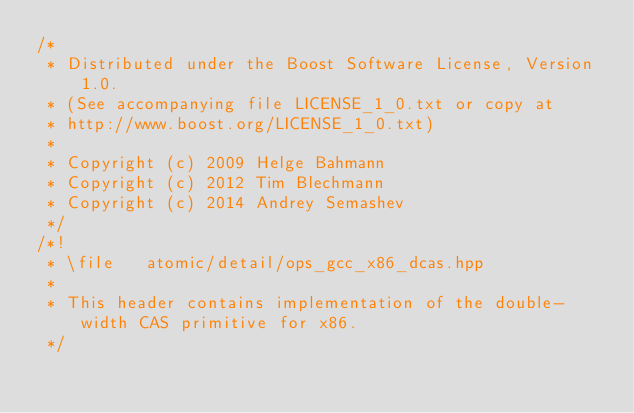<code> <loc_0><loc_0><loc_500><loc_500><_C++_>/*
 * Distributed under the Boost Software License, Version 1.0.
 * (See accompanying file LICENSE_1_0.txt or copy at
 * http://www.boost.org/LICENSE_1_0.txt)
 *
 * Copyright (c) 2009 Helge Bahmann
 * Copyright (c) 2012 Tim Blechmann
 * Copyright (c) 2014 Andrey Semashev
 */
/*!
 * \file   atomic/detail/ops_gcc_x86_dcas.hpp
 *
 * This header contains implementation of the double-width CAS primitive for x86.
 */
</code> 